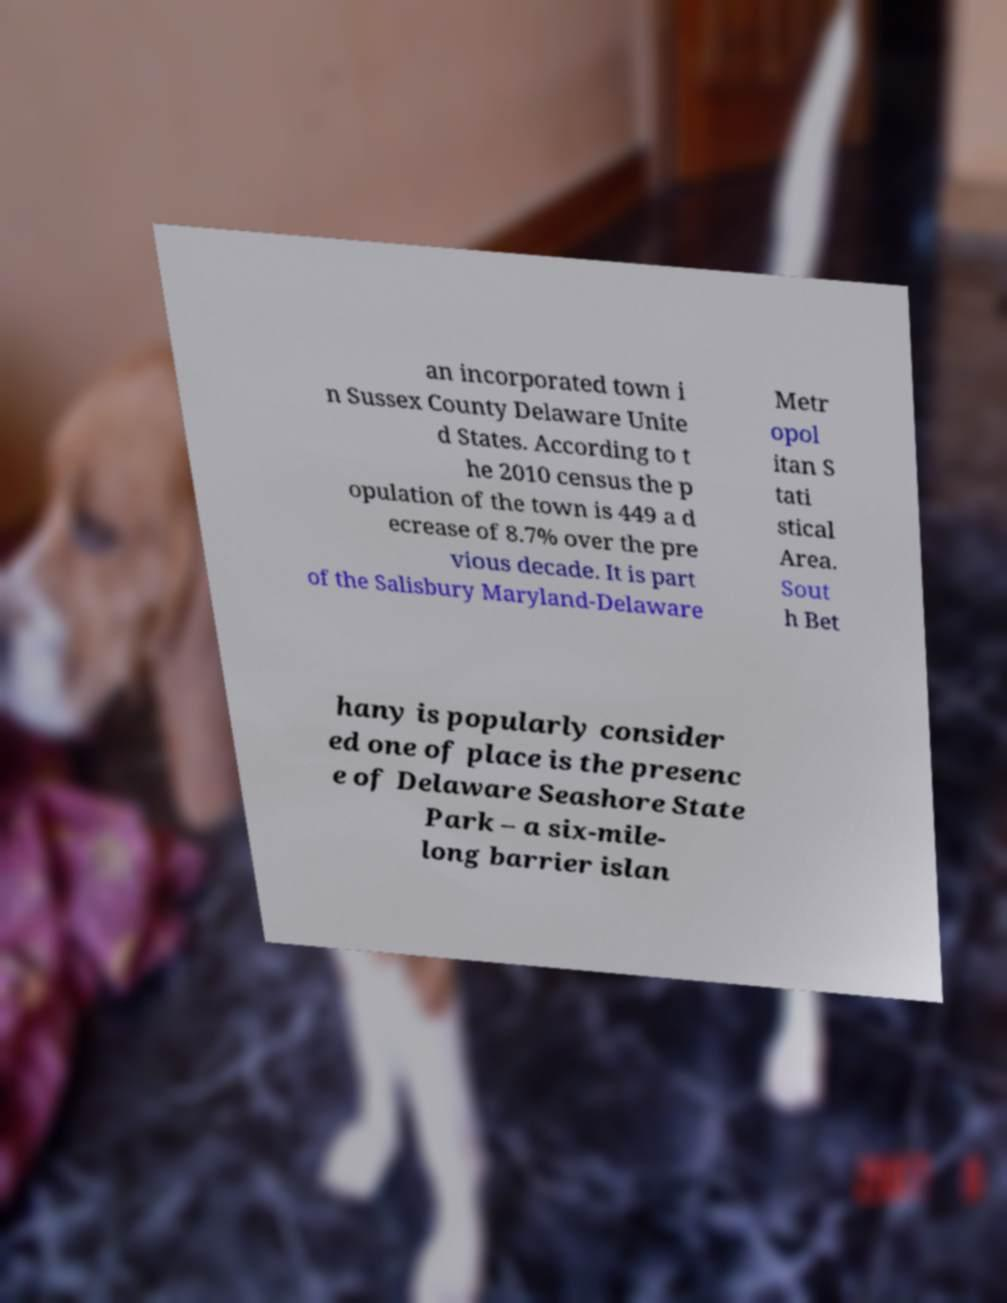Please identify and transcribe the text found in this image. an incorporated town i n Sussex County Delaware Unite d States. According to t he 2010 census the p opulation of the town is 449 a d ecrease of 8.7% over the pre vious decade. It is part of the Salisbury Maryland-Delaware Metr opol itan S tati stical Area. Sout h Bet hany is popularly consider ed one of place is the presenc e of Delaware Seashore State Park – a six-mile- long barrier islan 